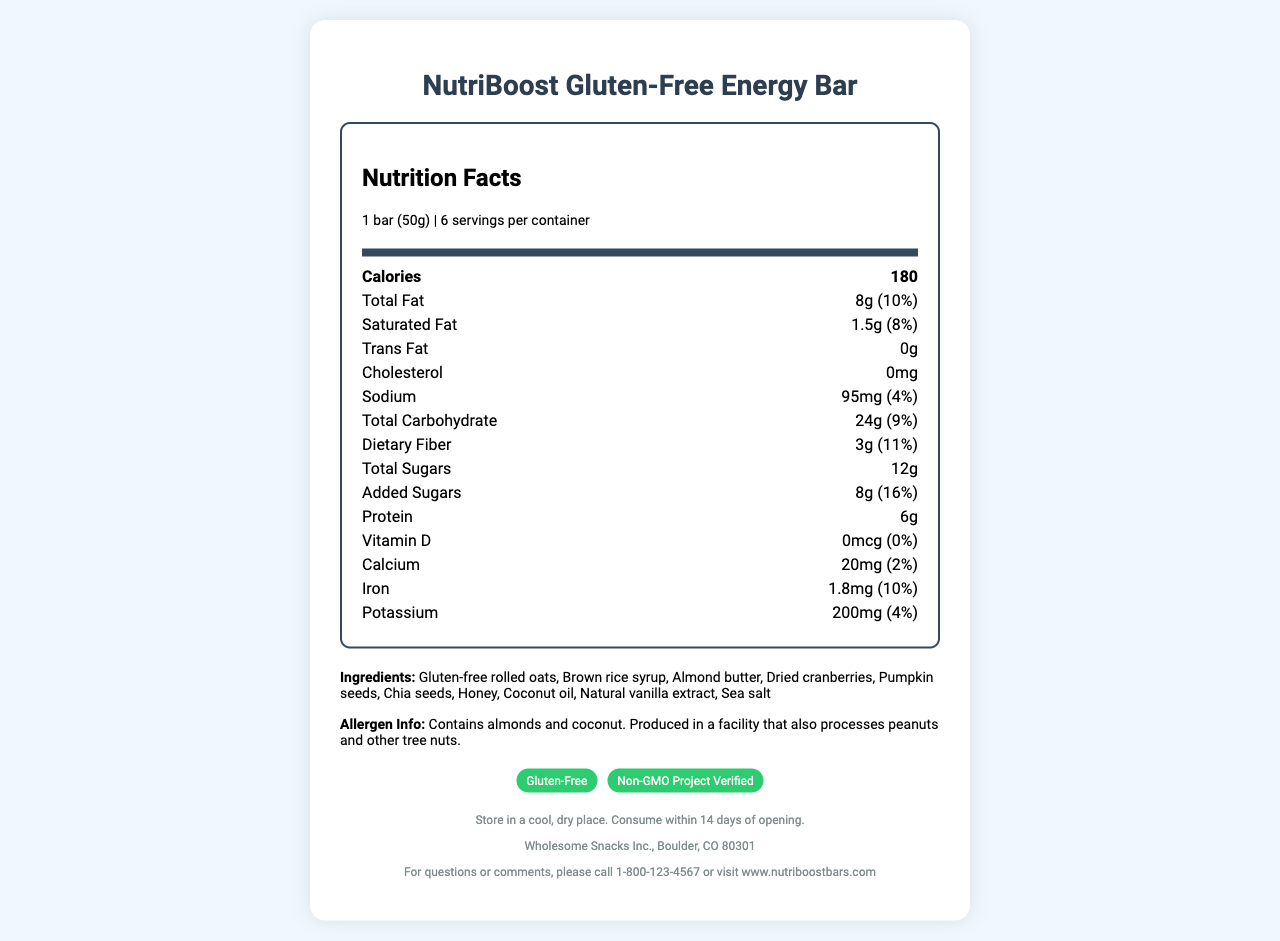How many servings are in a container of NutriBoost Gluten-Free Energy Bar? The document states that there are 6 servings per container.
Answer: 6 What is the amount of dietary fiber per serving? The document indicates that there are 3g of dietary fiber per serving.
Answer: 3g How much cholesterol is in one bar? The document shows 0mg of cholesterol in one bar.
Answer: 0mg How many calories are in one serving of the NutriBoost Gluten-Free Energy Bar? The document lists the calorie count as 180 per serving.
Answer: 180 What is the daily value percentage of iron per serving? According to the document, the daily value of iron per serving is 10%.
Answer: 10% What are the main ingredients of the NutriBoost Gluten-Free Energy Bar? The document lists these as the main ingredients.
Answer: Gluten-free rolled oats, Brown rice syrup, Almond butter, Dried cranberries, Pumpkin seeds, Chia seeds, Honey, Coconut oil, Natural vanilla extract, Sea salt What are the certifications for the NutriBoost Gluten-Free Energy Bar? The document states that the bar is certified as Gluten-Free and Non-GMO Project Verified.
Answer: Gluten-Free and Non-GMO Project Verified What is the total amount of sugars in one serving? The document specifies that there are 12g of total sugars per serving.
Answer: 12g Which of the following is not listed as an allergen in NutriBoost Gluten-Free Energy Bar? A. Almonds B. Coconut C. Peanuts D. Wheat The document lists almonds and coconut as allergens and mentions that the product is produced in a facility that processes peanuts, but wheat is not listed.
Answer: D How many grams of protein are in one bar? The document indicates that one bar contains 6g of protein.
Answer: 6g Is there any vitamin D in NutriBoost Gluten-Free Energy Bar? The document states that the amount of vitamin D is 0mcg, equating to 0% of the daily value.
Answer: No Where is the manufacturer's location? The document states that the manufacturer is located in Boulder, CO 80301.
Answer: Boulder, CO 80301 Which ingredient is used as a natural sweetener in the NutriBoost Gluten-Free Energy Bar? A. Brown rice syrup B. Corn syrup C. Maple syrup D. Agave nectar The document mentions Brown rice syrup as one of the ingredients, which is used as a natural sweetener.
Answer: A Does the NutriBoost Gluten-Free Energy Bar contain any trans fat? The document lists 0g of trans fat.
Answer: No Summarize the main details of the NutriBoost Gluten-Free Energy Bar described in the document. The document provides comprehensive information about the NutriBoost Gluten-Free Energy Bar, including nutritional facts, ingredients, certifications, allergens, and storage instructions.
Answer: The NutriBoost Gluten-Free Energy Bar is a nutritious snack with 180 calories per serving, made from gluten-free rolled oats, brown rice syrup, almond butter, and other natural ingredients. It is certified Gluten-Free and Non-GMO Project Verified, with significant amounts of dietary fiber and protein, while being free from cholesterol and trans fats. The bar contains ingredients like almonds and coconut and is produced in a facility that also processes peanuts and other tree nuts. What is the source of the natural vanilla extract in the NutriBoost Gluten-Free Energy Bar? The document does not provide information about the source of the natural vanilla extract.
Answer: Cannot be determined 